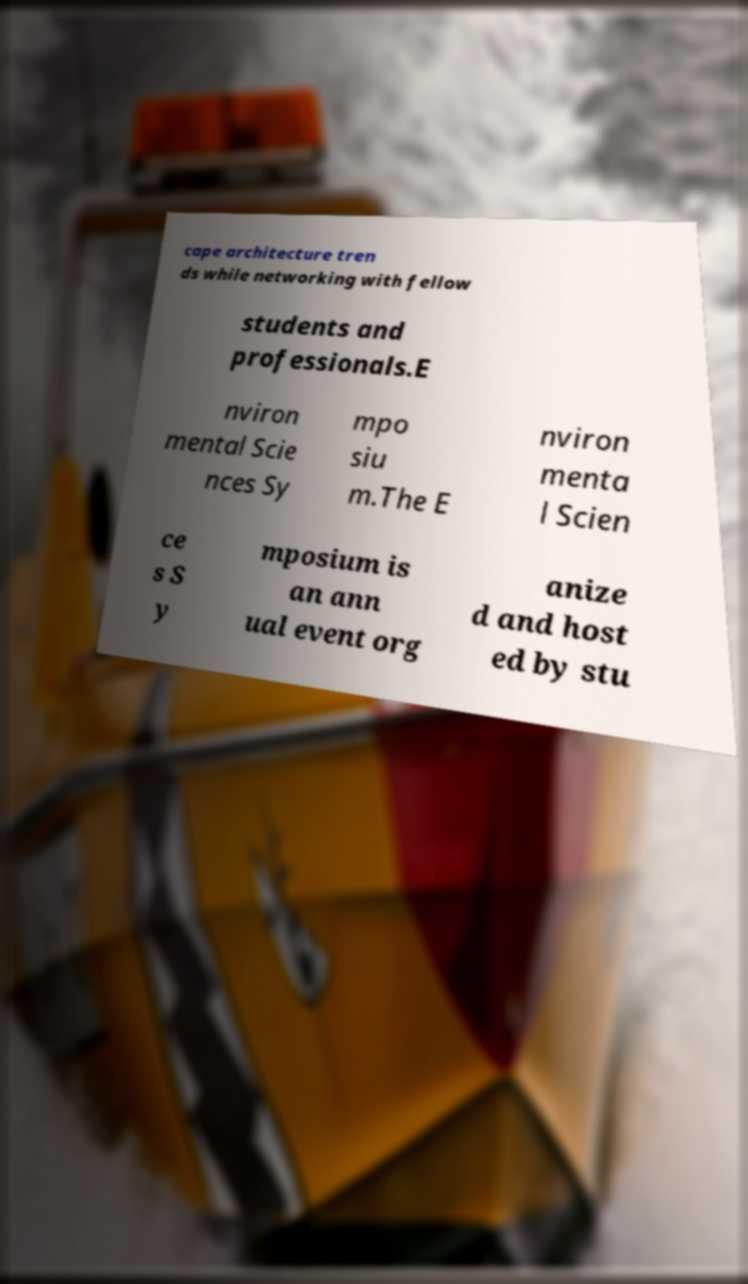Could you assist in decoding the text presented in this image and type it out clearly? cape architecture tren ds while networking with fellow students and professionals.E nviron mental Scie nces Sy mpo siu m.The E nviron menta l Scien ce s S y mposium is an ann ual event org anize d and host ed by stu 